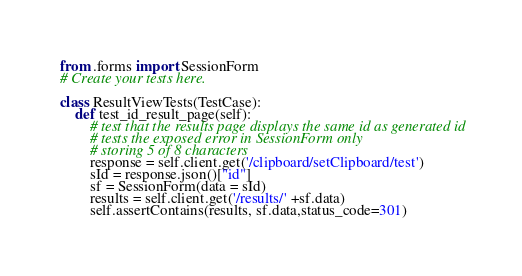<code> <loc_0><loc_0><loc_500><loc_500><_Python_>from .forms import SessionForm
# Create your tests here.

class ResultViewTests(TestCase):
	def test_id_result_page(self):
		# test that the results page displays the same id as generated id
		# tests the exposed error in SessionForm only 
		# storing 5 of 8 characters
		response = self.client.get('/clipboard/setClipboard/test')
		sId = response.json()["id"]
		sf = SessionForm(data = sId)
		results = self.client.get('/results/' +sf.data)
		self.assertContains(results, sf.data,status_code=301)


</code> 